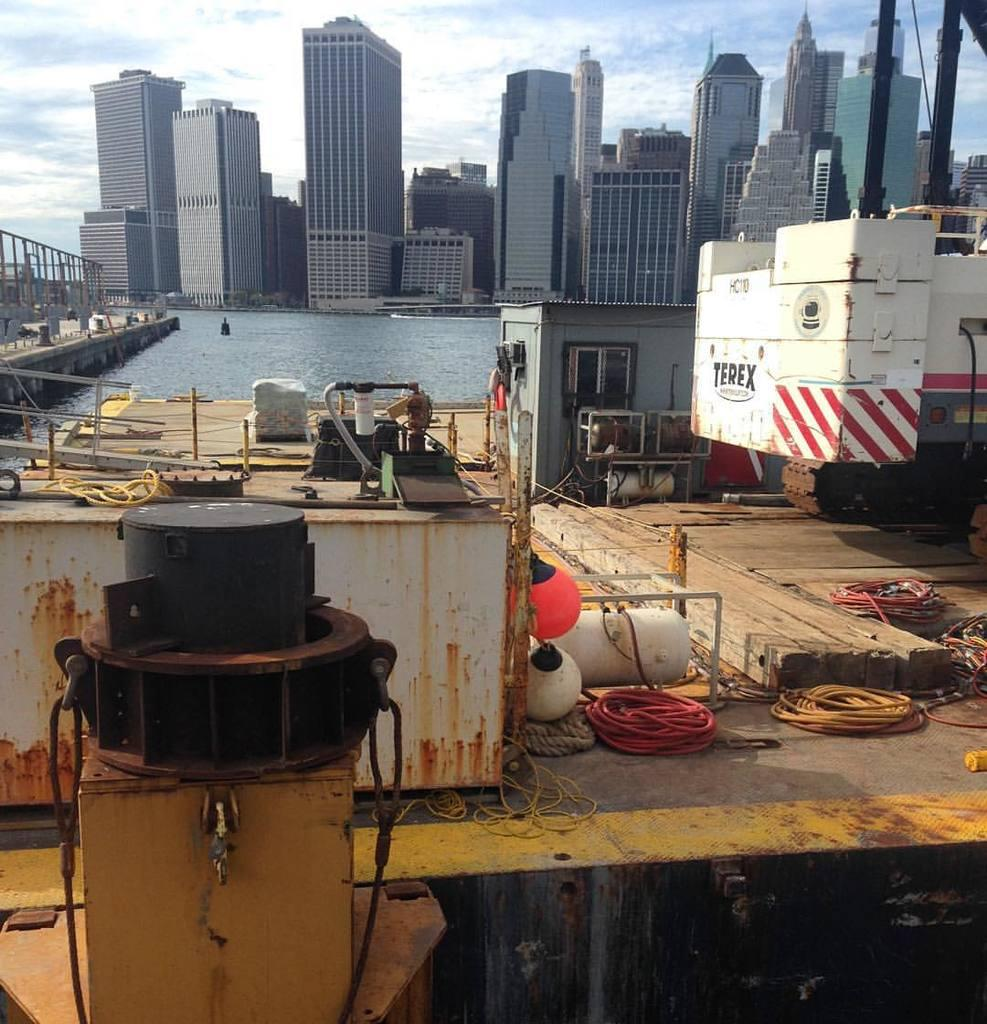What type of buildings can be seen in the image? There are many skyscrapers in the image. What is the condition of the sky in the image? The sky is cloudy at the top of the image. What body of water is present in the image? There is a sea in the center of the image. What type of structure can be seen at the left side of the image? There is a bridge at the left side of the image. How many trees are visible in the image? There are no trees visible in the image; it features skyscrapers, a sea, a bridge, and a cloudy sky. What is the rate of the bridge's movement in the image? The bridge is not moving in the image, so there is no rate of movement to determine. 